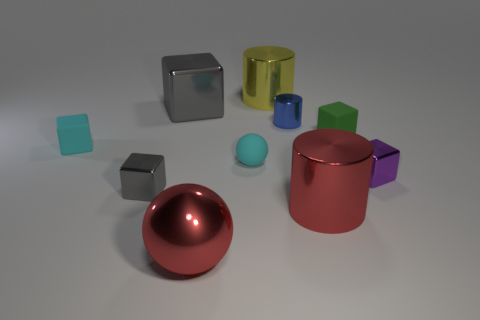Subtract all cyan blocks. How many blocks are left? 4 Subtract all purple blocks. How many blocks are left? 4 Subtract 3 cylinders. How many cylinders are left? 0 Subtract all cylinders. How many objects are left? 7 Subtract all blue cylinders. How many gray balls are left? 0 Subtract all yellow cylinders. Subtract all tiny blue shiny cylinders. How many objects are left? 8 Add 7 tiny green rubber things. How many tiny green rubber things are left? 8 Add 9 tiny yellow matte blocks. How many tiny yellow matte blocks exist? 9 Subtract 1 red cylinders. How many objects are left? 9 Subtract all cyan cylinders. Subtract all brown balls. How many cylinders are left? 3 